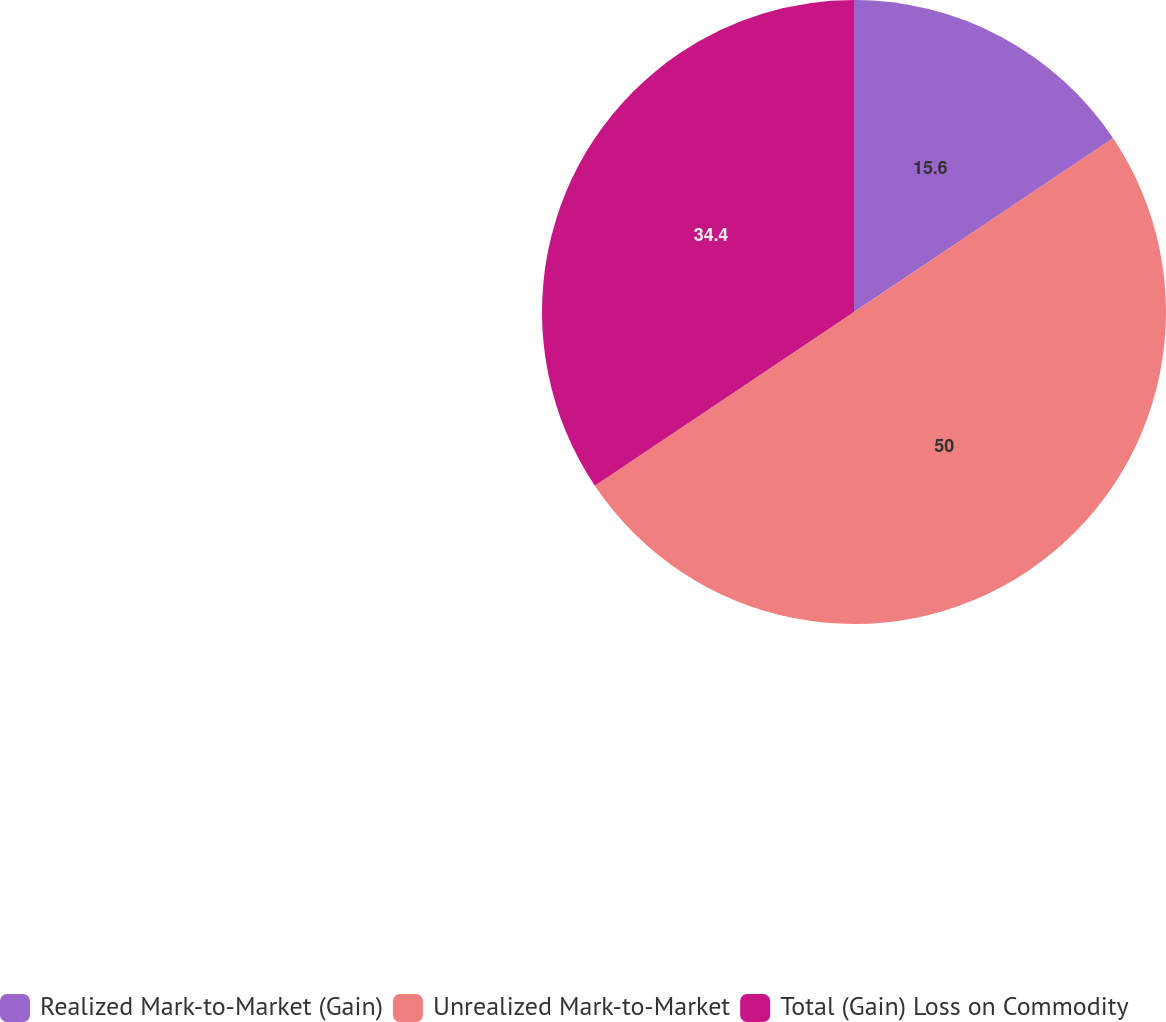Convert chart. <chart><loc_0><loc_0><loc_500><loc_500><pie_chart><fcel>Realized Mark-to-Market (Gain)<fcel>Unrealized Mark-to-Market<fcel>Total (Gain) Loss on Commodity<nl><fcel>15.6%<fcel>50.0%<fcel>34.4%<nl></chart> 